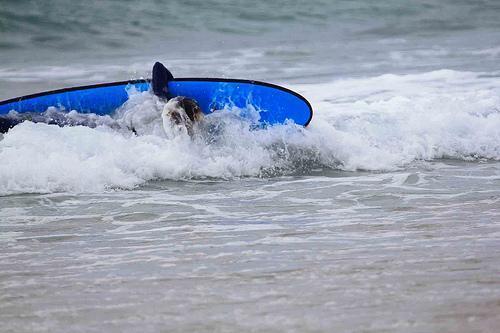How many people surfing?
Give a very brief answer. 1. 